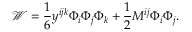<formula> <loc_0><loc_0><loc_500><loc_500>{ \mathcal { W } } = \frac { 1 } { 6 } y ^ { i j k } \Phi _ { i } \Phi _ { j } \Phi _ { k } + \frac { 1 } { 2 } M ^ { i j } \Phi _ { i } \Phi _ { j } .</formula> 